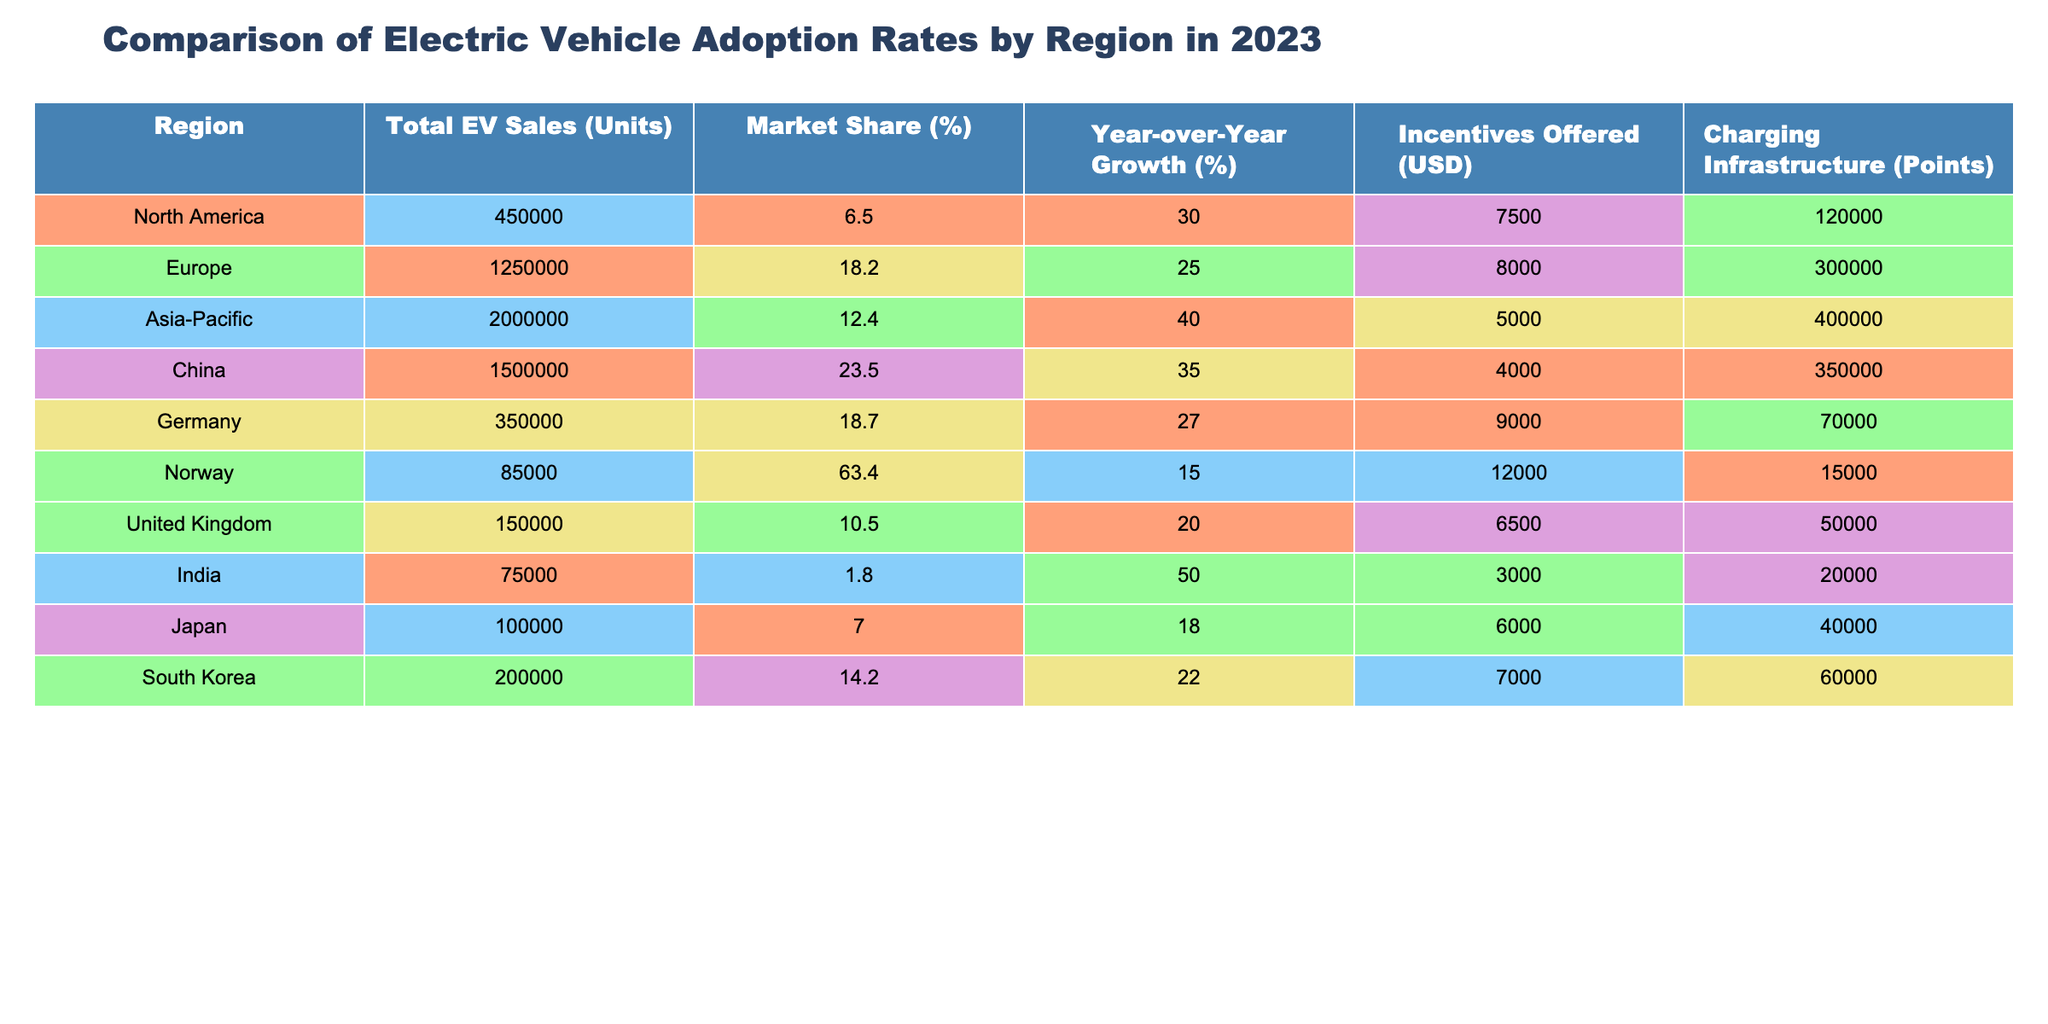What is the region with the highest total EV sales in 2023? Looking at the column for "Total EV Sales (Units)", Asia-Pacific shows the highest value at 2,000,000 units.
Answer: Asia-Pacific Which region has the highest market share percentage for EVs? The "Market Share (%)" for each region shows that China has the highest value at 23.5%.
Answer: China What is the year-over-year growth percentage for Europe? The "Year-over-Year Growth (%)" column specifies that Europe has a growth rate of 25%.
Answer: 25% How many charging infrastructure points does Norway have compared to India? Norway has 15,000 charging points, while India has 20,000. Comparing these numbers, India has more charging points than Norway.
Answer: India has more charging points What is the average total EV sales across all listed regions? Summing the total EV sales: 450,000 + 1,250,000 + 2,000,000 + 1,500,000 + 350,000 + 85,000 + 150,000 + 75,000 + 100,000 + 200,000 = 6,710,000. Dividing by the number of regions (10) gives an average of 671,000.
Answer: 671,000 Does any region have a market share of over 60%? By inspecting the table, Norway has the highest market share at 63.4%, which is over 60%.
Answer: Yes Which region of the table has the least EV market share and how much is it? The data shows that India has the least market share percentage at 1.8%.
Answer: India, 1.8% How does the year-over-year growth of Asia-Pacific compare to the growth of North America? Asia-Pacific has a year-over-year growth percentage of 40%, while North America has 30%. Comparing these, Asia-Pacific has a higher growth rate than North America.
Answer: Asia-Pacific is higher What is the difference in incentives offered between Germany and the United Kingdom? Germany offers $9,000 in incentives, and the United Kingdom offers $6,500. The difference is $9,000 - $6,500 = $2,500.
Answer: $2,500 Which region has the highest year-over-year growth, and what is that percentage? Looking at the "Year-over-Year Growth (%)" column, Asia-Pacific has the highest growth rate at 40%.
Answer: Asia-Pacific, 40% 